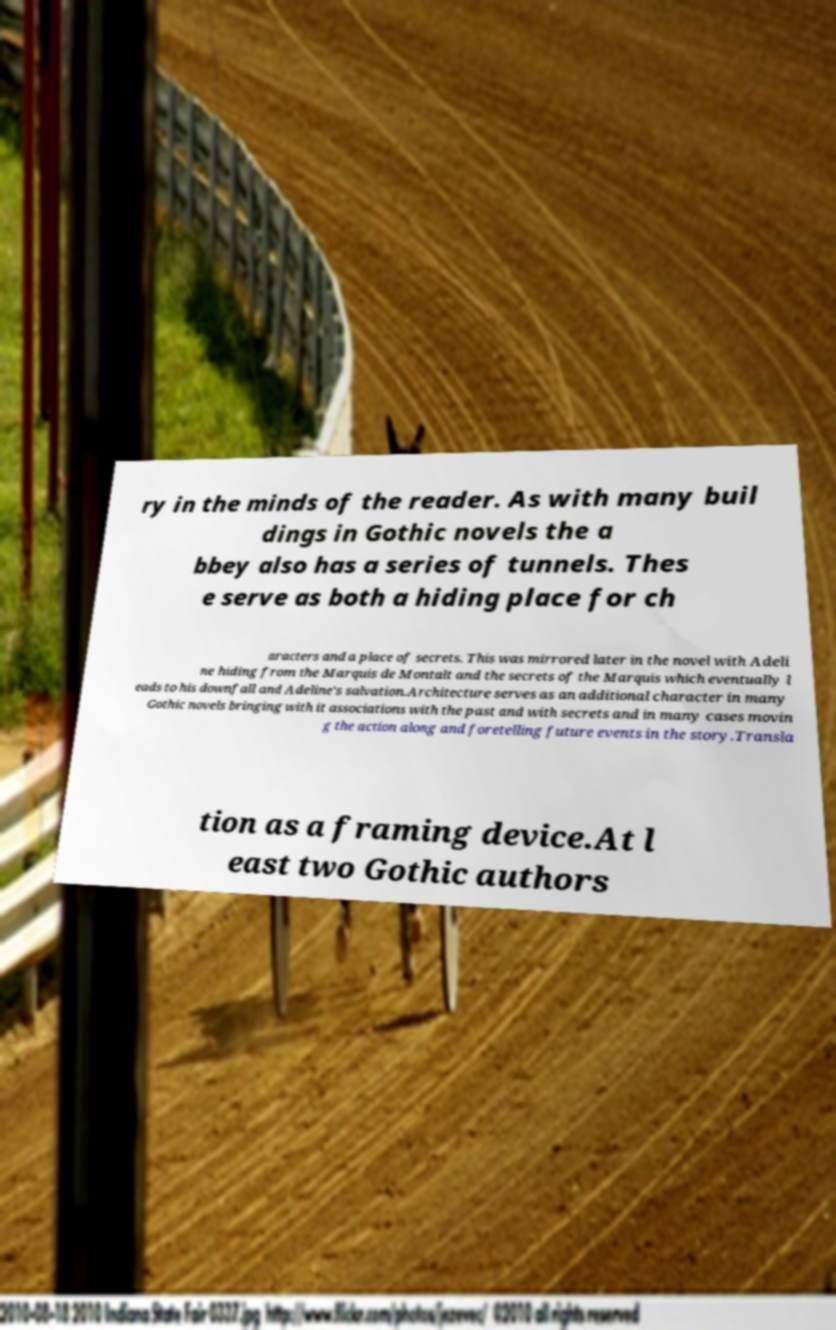I need the written content from this picture converted into text. Can you do that? ry in the minds of the reader. As with many buil dings in Gothic novels the a bbey also has a series of tunnels. Thes e serve as both a hiding place for ch aracters and a place of secrets. This was mirrored later in the novel with Adeli ne hiding from the Marquis de Montalt and the secrets of the Marquis which eventually l eads to his downfall and Adeline's salvation.Architecture serves as an additional character in many Gothic novels bringing with it associations with the past and with secrets and in many cases movin g the action along and foretelling future events in the story.Transla tion as a framing device.At l east two Gothic authors 